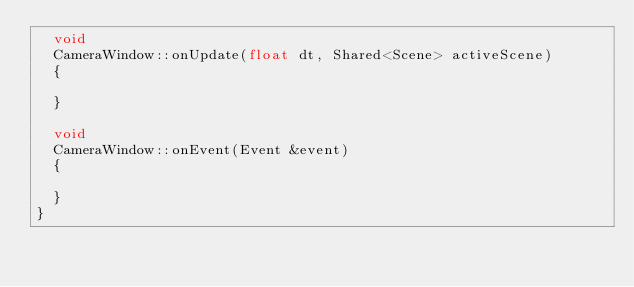<code> <loc_0><loc_0><loc_500><loc_500><_C++_>  void
  CameraWindow::onUpdate(float dt, Shared<Scene> activeScene)
  {

  }

  void
  CameraWindow::onEvent(Event &event)
  {

  }
}
</code> 